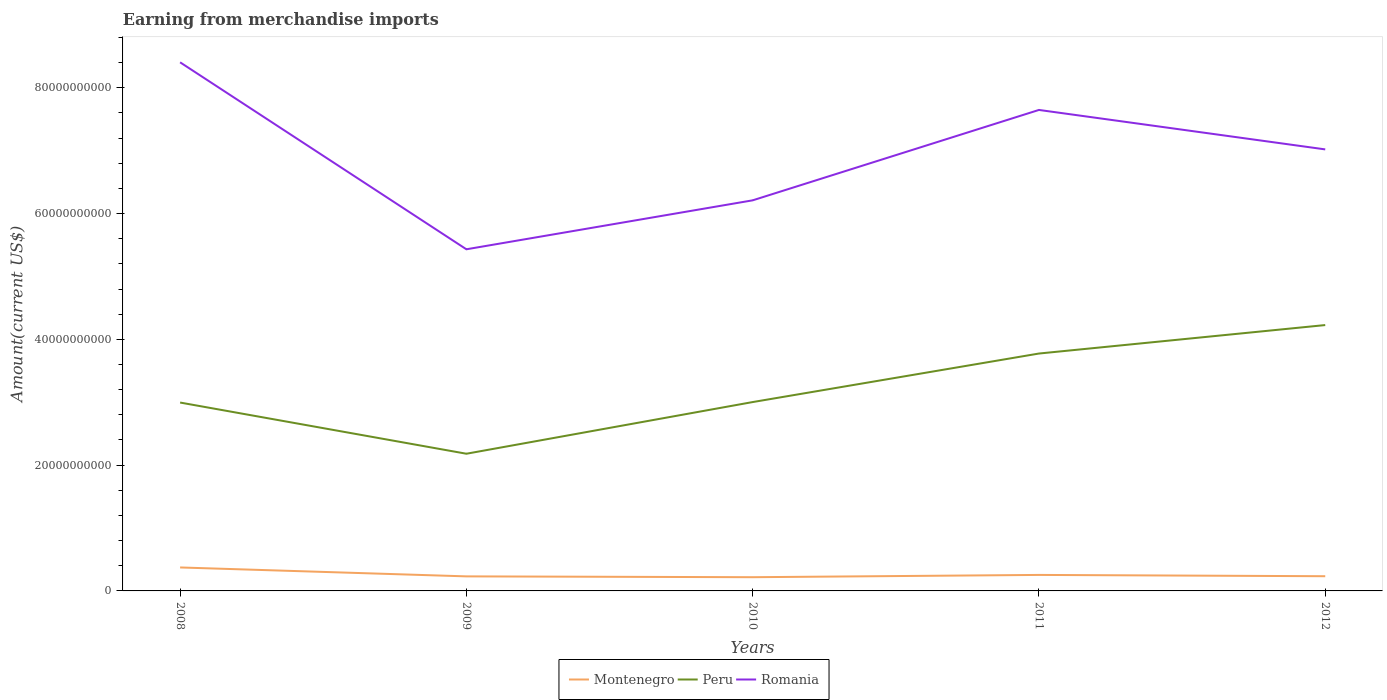How many different coloured lines are there?
Give a very brief answer. 3. Does the line corresponding to Montenegro intersect with the line corresponding to Romania?
Provide a short and direct response. No. Is the number of lines equal to the number of legend labels?
Offer a terse response. Yes. Across all years, what is the maximum amount earned from merchandise imports in Romania?
Give a very brief answer. 5.43e+1. What is the total amount earned from merchandise imports in Montenegro in the graph?
Make the answer very short. 1.39e+09. What is the difference between the highest and the second highest amount earned from merchandise imports in Montenegro?
Your response must be concise. 1.55e+09. Is the amount earned from merchandise imports in Peru strictly greater than the amount earned from merchandise imports in Montenegro over the years?
Provide a succinct answer. No. How many years are there in the graph?
Your answer should be very brief. 5. Are the values on the major ticks of Y-axis written in scientific E-notation?
Offer a terse response. No. Does the graph contain grids?
Ensure brevity in your answer.  No. How are the legend labels stacked?
Give a very brief answer. Horizontal. What is the title of the graph?
Ensure brevity in your answer.  Earning from merchandise imports. Does "New Caledonia" appear as one of the legend labels in the graph?
Offer a terse response. No. What is the label or title of the Y-axis?
Make the answer very short. Amount(current US$). What is the Amount(current US$) of Montenegro in 2008?
Give a very brief answer. 3.73e+09. What is the Amount(current US$) of Peru in 2008?
Your answer should be very brief. 3.00e+1. What is the Amount(current US$) of Romania in 2008?
Offer a terse response. 8.41e+1. What is the Amount(current US$) of Montenegro in 2009?
Your answer should be very brief. 2.31e+09. What is the Amount(current US$) of Peru in 2009?
Provide a succinct answer. 2.18e+1. What is the Amount(current US$) in Romania in 2009?
Keep it short and to the point. 5.43e+1. What is the Amount(current US$) in Montenegro in 2010?
Your answer should be very brief. 2.18e+09. What is the Amount(current US$) in Peru in 2010?
Provide a short and direct response. 3.00e+1. What is the Amount(current US$) in Romania in 2010?
Make the answer very short. 6.21e+1. What is the Amount(current US$) in Montenegro in 2011?
Give a very brief answer. 2.54e+09. What is the Amount(current US$) of Peru in 2011?
Offer a very short reply. 3.77e+1. What is the Amount(current US$) of Romania in 2011?
Your answer should be compact. 7.65e+1. What is the Amount(current US$) in Montenegro in 2012?
Offer a terse response. 2.34e+09. What is the Amount(current US$) of Peru in 2012?
Provide a short and direct response. 4.23e+1. What is the Amount(current US$) of Romania in 2012?
Offer a terse response. 7.02e+1. Across all years, what is the maximum Amount(current US$) in Montenegro?
Provide a succinct answer. 3.73e+09. Across all years, what is the maximum Amount(current US$) in Peru?
Make the answer very short. 4.23e+1. Across all years, what is the maximum Amount(current US$) in Romania?
Provide a succinct answer. 8.41e+1. Across all years, what is the minimum Amount(current US$) in Montenegro?
Give a very brief answer. 2.18e+09. Across all years, what is the minimum Amount(current US$) in Peru?
Provide a short and direct response. 2.18e+1. Across all years, what is the minimum Amount(current US$) in Romania?
Keep it short and to the point. 5.43e+1. What is the total Amount(current US$) in Montenegro in the graph?
Make the answer very short. 1.31e+1. What is the total Amount(current US$) of Peru in the graph?
Give a very brief answer. 1.62e+11. What is the total Amount(current US$) in Romania in the graph?
Your answer should be compact. 3.47e+11. What is the difference between the Amount(current US$) of Montenegro in 2008 and that in 2009?
Provide a short and direct response. 1.42e+09. What is the difference between the Amount(current US$) of Peru in 2008 and that in 2009?
Offer a terse response. 8.14e+09. What is the difference between the Amount(current US$) in Romania in 2008 and that in 2009?
Provide a succinct answer. 2.97e+1. What is the difference between the Amount(current US$) in Montenegro in 2008 and that in 2010?
Offer a very short reply. 1.55e+09. What is the difference between the Amount(current US$) of Peru in 2008 and that in 2010?
Your response must be concise. -7.77e+07. What is the difference between the Amount(current US$) of Romania in 2008 and that in 2010?
Your answer should be very brief. 2.19e+1. What is the difference between the Amount(current US$) of Montenegro in 2008 and that in 2011?
Your answer should be compact. 1.19e+09. What is the difference between the Amount(current US$) of Peru in 2008 and that in 2011?
Your response must be concise. -7.79e+09. What is the difference between the Amount(current US$) of Romania in 2008 and that in 2011?
Keep it short and to the point. 7.57e+09. What is the difference between the Amount(current US$) of Montenegro in 2008 and that in 2012?
Your response must be concise. 1.39e+09. What is the difference between the Amount(current US$) in Peru in 2008 and that in 2012?
Keep it short and to the point. -1.23e+1. What is the difference between the Amount(current US$) of Romania in 2008 and that in 2012?
Make the answer very short. 1.38e+1. What is the difference between the Amount(current US$) in Montenegro in 2009 and that in 2010?
Your answer should be very brief. 1.31e+08. What is the difference between the Amount(current US$) of Peru in 2009 and that in 2010?
Offer a very short reply. -8.22e+09. What is the difference between the Amount(current US$) of Romania in 2009 and that in 2010?
Your response must be concise. -7.78e+09. What is the difference between the Amount(current US$) of Montenegro in 2009 and that in 2011?
Your answer should be compact. -2.31e+08. What is the difference between the Amount(current US$) of Peru in 2009 and that in 2011?
Offer a very short reply. -1.59e+1. What is the difference between the Amount(current US$) of Romania in 2009 and that in 2011?
Provide a short and direct response. -2.22e+1. What is the difference between the Amount(current US$) in Montenegro in 2009 and that in 2012?
Your response must be concise. -2.43e+07. What is the difference between the Amount(current US$) of Peru in 2009 and that in 2012?
Keep it short and to the point. -2.05e+1. What is the difference between the Amount(current US$) in Romania in 2009 and that in 2012?
Your response must be concise. -1.59e+1. What is the difference between the Amount(current US$) of Montenegro in 2010 and that in 2011?
Offer a very short reply. -3.62e+08. What is the difference between the Amount(current US$) in Peru in 2010 and that in 2011?
Provide a succinct answer. -7.72e+09. What is the difference between the Amount(current US$) in Romania in 2010 and that in 2011?
Provide a succinct answer. -1.44e+1. What is the difference between the Amount(current US$) of Montenegro in 2010 and that in 2012?
Give a very brief answer. -1.55e+08. What is the difference between the Amount(current US$) of Peru in 2010 and that in 2012?
Keep it short and to the point. -1.22e+1. What is the difference between the Amount(current US$) of Romania in 2010 and that in 2012?
Your answer should be very brief. -8.10e+09. What is the difference between the Amount(current US$) of Montenegro in 2011 and that in 2012?
Your response must be concise. 2.07e+08. What is the difference between the Amount(current US$) of Peru in 2011 and that in 2012?
Make the answer very short. -4.53e+09. What is the difference between the Amount(current US$) of Romania in 2011 and that in 2012?
Provide a succinct answer. 6.27e+09. What is the difference between the Amount(current US$) in Montenegro in 2008 and the Amount(current US$) in Peru in 2009?
Give a very brief answer. -1.81e+1. What is the difference between the Amount(current US$) of Montenegro in 2008 and the Amount(current US$) of Romania in 2009?
Provide a succinct answer. -5.06e+1. What is the difference between the Amount(current US$) of Peru in 2008 and the Amount(current US$) of Romania in 2009?
Provide a short and direct response. -2.44e+1. What is the difference between the Amount(current US$) in Montenegro in 2008 and the Amount(current US$) in Peru in 2010?
Keep it short and to the point. -2.63e+1. What is the difference between the Amount(current US$) in Montenegro in 2008 and the Amount(current US$) in Romania in 2010?
Ensure brevity in your answer.  -5.84e+1. What is the difference between the Amount(current US$) of Peru in 2008 and the Amount(current US$) of Romania in 2010?
Your answer should be very brief. -3.22e+1. What is the difference between the Amount(current US$) of Montenegro in 2008 and the Amount(current US$) of Peru in 2011?
Ensure brevity in your answer.  -3.40e+1. What is the difference between the Amount(current US$) of Montenegro in 2008 and the Amount(current US$) of Romania in 2011?
Your answer should be compact. -7.27e+1. What is the difference between the Amount(current US$) in Peru in 2008 and the Amount(current US$) in Romania in 2011?
Provide a succinct answer. -4.65e+1. What is the difference between the Amount(current US$) of Montenegro in 2008 and the Amount(current US$) of Peru in 2012?
Give a very brief answer. -3.85e+1. What is the difference between the Amount(current US$) of Montenegro in 2008 and the Amount(current US$) of Romania in 2012?
Give a very brief answer. -6.65e+1. What is the difference between the Amount(current US$) of Peru in 2008 and the Amount(current US$) of Romania in 2012?
Keep it short and to the point. -4.03e+1. What is the difference between the Amount(current US$) of Montenegro in 2009 and the Amount(current US$) of Peru in 2010?
Your answer should be compact. -2.77e+1. What is the difference between the Amount(current US$) in Montenegro in 2009 and the Amount(current US$) in Romania in 2010?
Provide a short and direct response. -5.98e+1. What is the difference between the Amount(current US$) of Peru in 2009 and the Amount(current US$) of Romania in 2010?
Offer a very short reply. -4.03e+1. What is the difference between the Amount(current US$) of Montenegro in 2009 and the Amount(current US$) of Peru in 2011?
Offer a very short reply. -3.54e+1. What is the difference between the Amount(current US$) of Montenegro in 2009 and the Amount(current US$) of Romania in 2011?
Keep it short and to the point. -7.42e+1. What is the difference between the Amount(current US$) in Peru in 2009 and the Amount(current US$) in Romania in 2011?
Offer a very short reply. -5.47e+1. What is the difference between the Amount(current US$) of Montenegro in 2009 and the Amount(current US$) of Peru in 2012?
Make the answer very short. -4.00e+1. What is the difference between the Amount(current US$) in Montenegro in 2009 and the Amount(current US$) in Romania in 2012?
Offer a terse response. -6.79e+1. What is the difference between the Amount(current US$) in Peru in 2009 and the Amount(current US$) in Romania in 2012?
Ensure brevity in your answer.  -4.84e+1. What is the difference between the Amount(current US$) of Montenegro in 2010 and the Amount(current US$) of Peru in 2011?
Your response must be concise. -3.56e+1. What is the difference between the Amount(current US$) in Montenegro in 2010 and the Amount(current US$) in Romania in 2011?
Offer a very short reply. -7.43e+1. What is the difference between the Amount(current US$) in Peru in 2010 and the Amount(current US$) in Romania in 2011?
Your response must be concise. -4.64e+1. What is the difference between the Amount(current US$) of Montenegro in 2010 and the Amount(current US$) of Peru in 2012?
Offer a terse response. -4.01e+1. What is the difference between the Amount(current US$) of Montenegro in 2010 and the Amount(current US$) of Romania in 2012?
Offer a terse response. -6.80e+1. What is the difference between the Amount(current US$) in Peru in 2010 and the Amount(current US$) in Romania in 2012?
Your answer should be very brief. -4.02e+1. What is the difference between the Amount(current US$) in Montenegro in 2011 and the Amount(current US$) in Peru in 2012?
Your response must be concise. -3.97e+1. What is the difference between the Amount(current US$) of Montenegro in 2011 and the Amount(current US$) of Romania in 2012?
Offer a terse response. -6.77e+1. What is the difference between the Amount(current US$) in Peru in 2011 and the Amount(current US$) in Romania in 2012?
Your answer should be compact. -3.25e+1. What is the average Amount(current US$) of Montenegro per year?
Make the answer very short. 2.62e+09. What is the average Amount(current US$) in Peru per year?
Provide a short and direct response. 3.24e+1. What is the average Amount(current US$) in Romania per year?
Your response must be concise. 6.94e+1. In the year 2008, what is the difference between the Amount(current US$) of Montenegro and Amount(current US$) of Peru?
Offer a terse response. -2.62e+1. In the year 2008, what is the difference between the Amount(current US$) of Montenegro and Amount(current US$) of Romania?
Make the answer very short. -8.03e+1. In the year 2008, what is the difference between the Amount(current US$) in Peru and Amount(current US$) in Romania?
Provide a short and direct response. -5.41e+1. In the year 2009, what is the difference between the Amount(current US$) in Montenegro and Amount(current US$) in Peru?
Offer a very short reply. -1.95e+1. In the year 2009, what is the difference between the Amount(current US$) of Montenegro and Amount(current US$) of Romania?
Your answer should be very brief. -5.20e+1. In the year 2009, what is the difference between the Amount(current US$) of Peru and Amount(current US$) of Romania?
Make the answer very short. -3.25e+1. In the year 2010, what is the difference between the Amount(current US$) of Montenegro and Amount(current US$) of Peru?
Your answer should be very brief. -2.78e+1. In the year 2010, what is the difference between the Amount(current US$) of Montenegro and Amount(current US$) of Romania?
Your answer should be very brief. -5.99e+1. In the year 2010, what is the difference between the Amount(current US$) of Peru and Amount(current US$) of Romania?
Give a very brief answer. -3.21e+1. In the year 2011, what is the difference between the Amount(current US$) of Montenegro and Amount(current US$) of Peru?
Ensure brevity in your answer.  -3.52e+1. In the year 2011, what is the difference between the Amount(current US$) of Montenegro and Amount(current US$) of Romania?
Ensure brevity in your answer.  -7.39e+1. In the year 2011, what is the difference between the Amount(current US$) in Peru and Amount(current US$) in Romania?
Your response must be concise. -3.87e+1. In the year 2012, what is the difference between the Amount(current US$) of Montenegro and Amount(current US$) of Peru?
Keep it short and to the point. -3.99e+1. In the year 2012, what is the difference between the Amount(current US$) of Montenegro and Amount(current US$) of Romania?
Offer a very short reply. -6.79e+1. In the year 2012, what is the difference between the Amount(current US$) in Peru and Amount(current US$) in Romania?
Your response must be concise. -2.79e+1. What is the ratio of the Amount(current US$) of Montenegro in 2008 to that in 2009?
Your response must be concise. 1.61. What is the ratio of the Amount(current US$) in Peru in 2008 to that in 2009?
Your response must be concise. 1.37. What is the ratio of the Amount(current US$) in Romania in 2008 to that in 2009?
Give a very brief answer. 1.55. What is the ratio of the Amount(current US$) of Montenegro in 2008 to that in 2010?
Offer a terse response. 1.71. What is the ratio of the Amount(current US$) of Romania in 2008 to that in 2010?
Your answer should be very brief. 1.35. What is the ratio of the Amount(current US$) in Montenegro in 2008 to that in 2011?
Your answer should be very brief. 1.47. What is the ratio of the Amount(current US$) in Peru in 2008 to that in 2011?
Give a very brief answer. 0.79. What is the ratio of the Amount(current US$) in Romania in 2008 to that in 2011?
Provide a succinct answer. 1.1. What is the ratio of the Amount(current US$) in Montenegro in 2008 to that in 2012?
Offer a very short reply. 1.6. What is the ratio of the Amount(current US$) of Peru in 2008 to that in 2012?
Provide a succinct answer. 0.71. What is the ratio of the Amount(current US$) in Romania in 2008 to that in 2012?
Give a very brief answer. 1.2. What is the ratio of the Amount(current US$) of Montenegro in 2009 to that in 2010?
Your answer should be very brief. 1.06. What is the ratio of the Amount(current US$) of Peru in 2009 to that in 2010?
Your answer should be very brief. 0.73. What is the ratio of the Amount(current US$) of Romania in 2009 to that in 2010?
Your answer should be compact. 0.87. What is the ratio of the Amount(current US$) of Montenegro in 2009 to that in 2011?
Offer a very short reply. 0.91. What is the ratio of the Amount(current US$) of Peru in 2009 to that in 2011?
Make the answer very short. 0.58. What is the ratio of the Amount(current US$) in Romania in 2009 to that in 2011?
Offer a terse response. 0.71. What is the ratio of the Amount(current US$) in Montenegro in 2009 to that in 2012?
Offer a terse response. 0.99. What is the ratio of the Amount(current US$) in Peru in 2009 to that in 2012?
Make the answer very short. 0.52. What is the ratio of the Amount(current US$) in Romania in 2009 to that in 2012?
Offer a terse response. 0.77. What is the ratio of the Amount(current US$) of Montenegro in 2010 to that in 2011?
Ensure brevity in your answer.  0.86. What is the ratio of the Amount(current US$) of Peru in 2010 to that in 2011?
Give a very brief answer. 0.8. What is the ratio of the Amount(current US$) of Romania in 2010 to that in 2011?
Offer a terse response. 0.81. What is the ratio of the Amount(current US$) of Montenegro in 2010 to that in 2012?
Provide a succinct answer. 0.93. What is the ratio of the Amount(current US$) of Peru in 2010 to that in 2012?
Ensure brevity in your answer.  0.71. What is the ratio of the Amount(current US$) in Romania in 2010 to that in 2012?
Keep it short and to the point. 0.88. What is the ratio of the Amount(current US$) of Montenegro in 2011 to that in 2012?
Your answer should be compact. 1.09. What is the ratio of the Amount(current US$) of Peru in 2011 to that in 2012?
Provide a succinct answer. 0.89. What is the ratio of the Amount(current US$) in Romania in 2011 to that in 2012?
Your answer should be very brief. 1.09. What is the difference between the highest and the second highest Amount(current US$) in Montenegro?
Make the answer very short. 1.19e+09. What is the difference between the highest and the second highest Amount(current US$) in Peru?
Give a very brief answer. 4.53e+09. What is the difference between the highest and the second highest Amount(current US$) in Romania?
Your answer should be compact. 7.57e+09. What is the difference between the highest and the lowest Amount(current US$) of Montenegro?
Make the answer very short. 1.55e+09. What is the difference between the highest and the lowest Amount(current US$) of Peru?
Your response must be concise. 2.05e+1. What is the difference between the highest and the lowest Amount(current US$) of Romania?
Make the answer very short. 2.97e+1. 